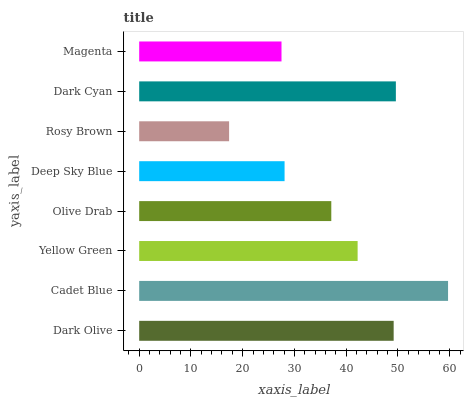Is Rosy Brown the minimum?
Answer yes or no. Yes. Is Cadet Blue the maximum?
Answer yes or no. Yes. Is Yellow Green the minimum?
Answer yes or no. No. Is Yellow Green the maximum?
Answer yes or no. No. Is Cadet Blue greater than Yellow Green?
Answer yes or no. Yes. Is Yellow Green less than Cadet Blue?
Answer yes or no. Yes. Is Yellow Green greater than Cadet Blue?
Answer yes or no. No. Is Cadet Blue less than Yellow Green?
Answer yes or no. No. Is Yellow Green the high median?
Answer yes or no. Yes. Is Olive Drab the low median?
Answer yes or no. Yes. Is Olive Drab the high median?
Answer yes or no. No. Is Magenta the low median?
Answer yes or no. No. 